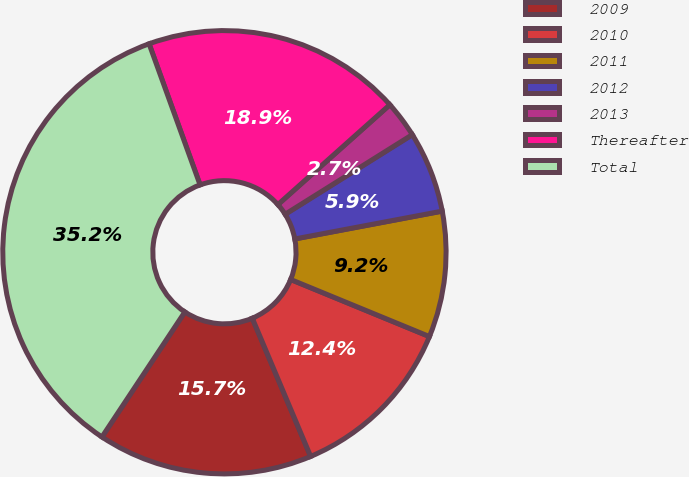Convert chart. <chart><loc_0><loc_0><loc_500><loc_500><pie_chart><fcel>2009<fcel>2010<fcel>2011<fcel>2012<fcel>2013<fcel>Thereafter<fcel>Total<nl><fcel>15.68%<fcel>12.43%<fcel>9.18%<fcel>5.93%<fcel>2.69%<fcel>18.93%<fcel>35.16%<nl></chart> 